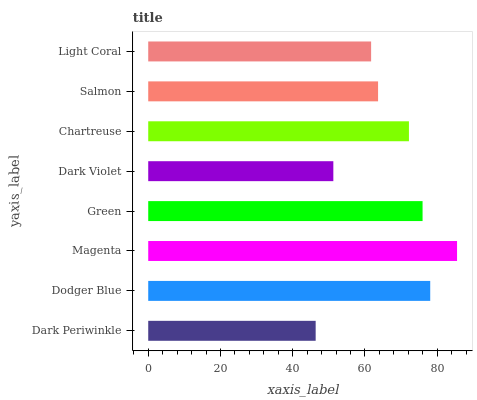Is Dark Periwinkle the minimum?
Answer yes or no. Yes. Is Magenta the maximum?
Answer yes or no. Yes. Is Dodger Blue the minimum?
Answer yes or no. No. Is Dodger Blue the maximum?
Answer yes or no. No. Is Dodger Blue greater than Dark Periwinkle?
Answer yes or no. Yes. Is Dark Periwinkle less than Dodger Blue?
Answer yes or no. Yes. Is Dark Periwinkle greater than Dodger Blue?
Answer yes or no. No. Is Dodger Blue less than Dark Periwinkle?
Answer yes or no. No. Is Chartreuse the high median?
Answer yes or no. Yes. Is Salmon the low median?
Answer yes or no. Yes. Is Dark Periwinkle the high median?
Answer yes or no. No. Is Green the low median?
Answer yes or no. No. 